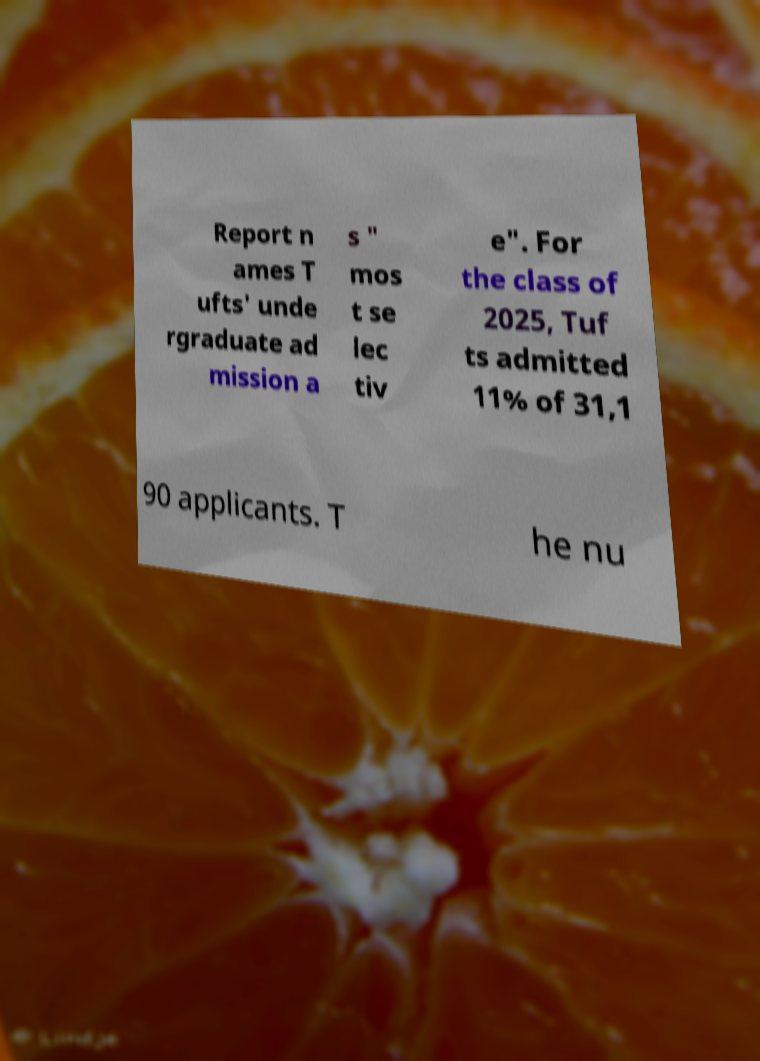Please identify and transcribe the text found in this image. Report n ames T ufts' unde rgraduate ad mission a s " mos t se lec tiv e". For the class of 2025, Tuf ts admitted 11% of 31,1 90 applicants. T he nu 